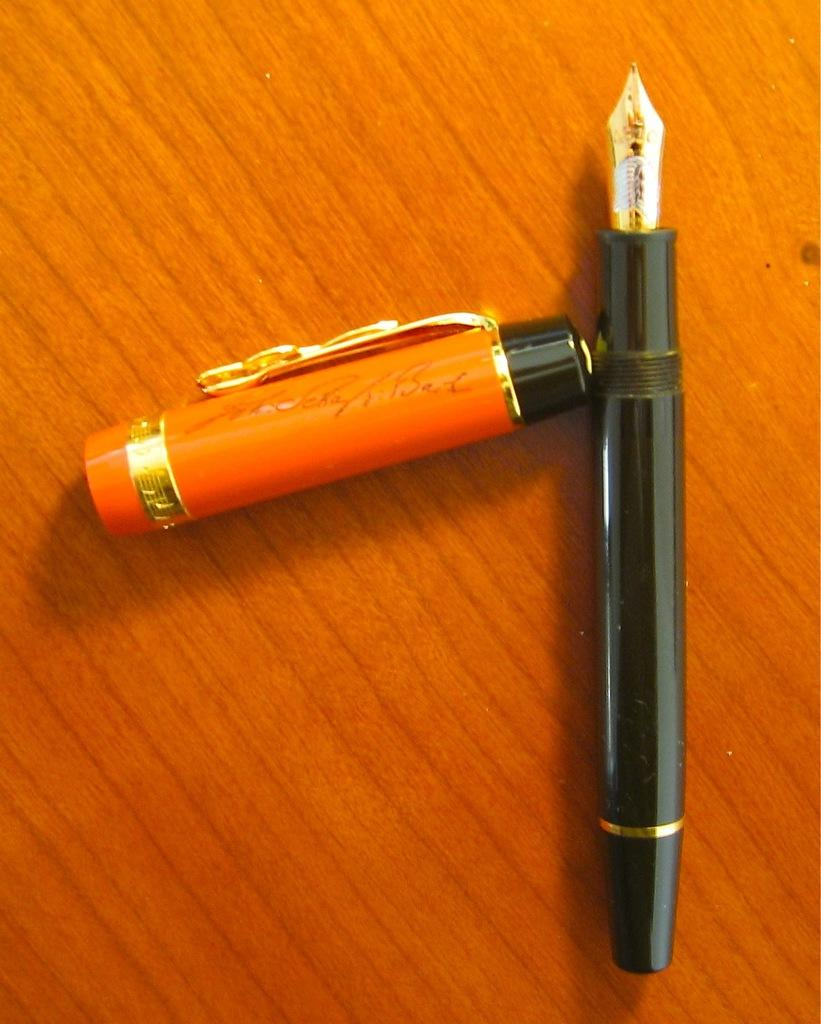What is the main object in the center of the image? There is a pen in the center of the image. What part of the pen is also visible in the image? There is a cap of the pen in the image. Is there any text or markings on the pen cap? Yes, there is text written on the pen cap. Can you see a sink in the image? No, there is no sink present in the image. What observation can be made about the pen's functionality in the image? The image does not show the pen being used or its functionality; it only shows the pen and its cap. 